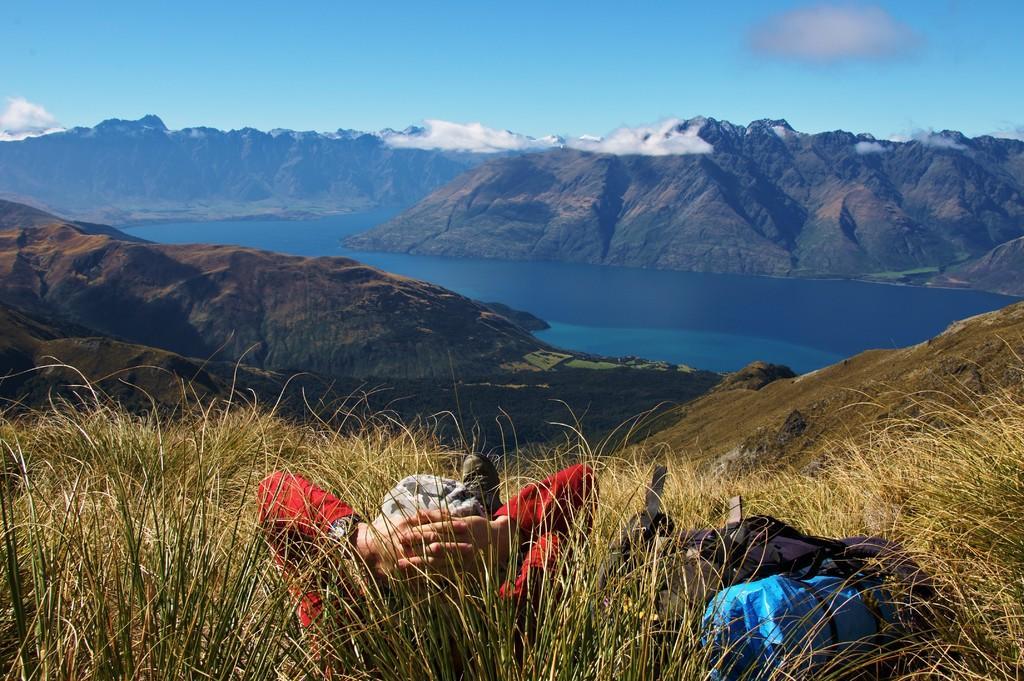Could you give a brief overview of what you see in this image? There is a person laying on the grass. Here we can see bags, water, and mountains. In the background there is sky with clouds. 